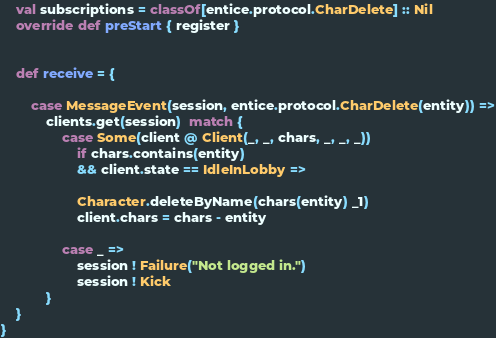Convert code to text. <code><loc_0><loc_0><loc_500><loc_500><_Scala_>    val subscriptions = classOf[entice.protocol.CharDelete] :: Nil
    override def preStart { register }


    def receive = {

        case MessageEvent(session, entice.protocol.CharDelete(entity)) =>
            clients.get(session)  match {
                case Some(client @ Client(_, _, chars, _, _, _)) 
                    if chars.contains(entity)
                    && client.state == IdleInLobby =>
                
                    Character.deleteByName(chars(entity) _1)
                    client.chars = chars - entity
 
                case _ =>
                    session ! Failure("Not logged in.")
                    session ! Kick
            }
    }
}</code> 